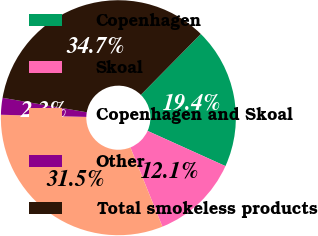Convert chart to OTSL. <chart><loc_0><loc_0><loc_500><loc_500><pie_chart><fcel>Copenhagen<fcel>Skoal<fcel>Copenhagen and Skoal<fcel>Other<fcel>Total smokeless products<nl><fcel>19.38%<fcel>12.13%<fcel>31.51%<fcel>2.31%<fcel>34.66%<nl></chart> 